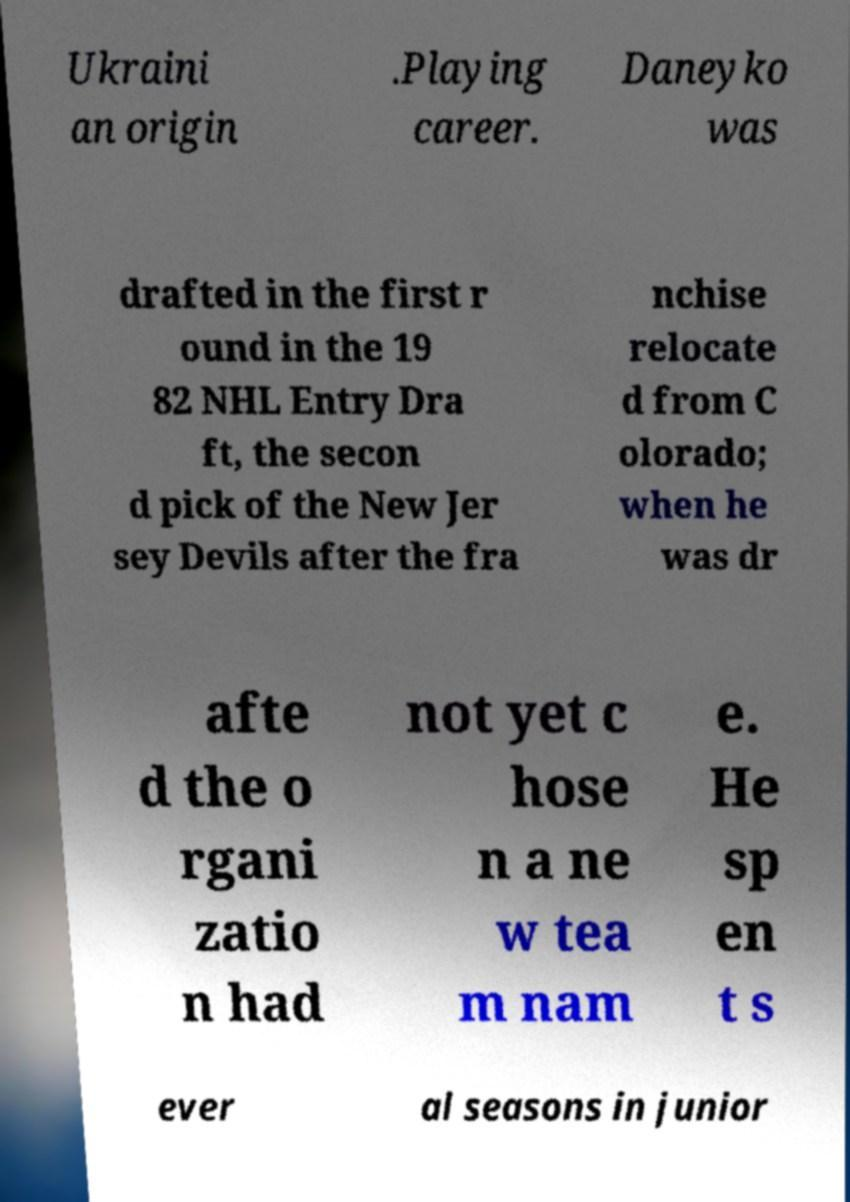Could you extract and type out the text from this image? Ukraini an origin .Playing career. Daneyko was drafted in the first r ound in the 19 82 NHL Entry Dra ft, the secon d pick of the New Jer sey Devils after the fra nchise relocate d from C olorado; when he was dr afte d the o rgani zatio n had not yet c hose n a ne w tea m nam e. He sp en t s ever al seasons in junior 